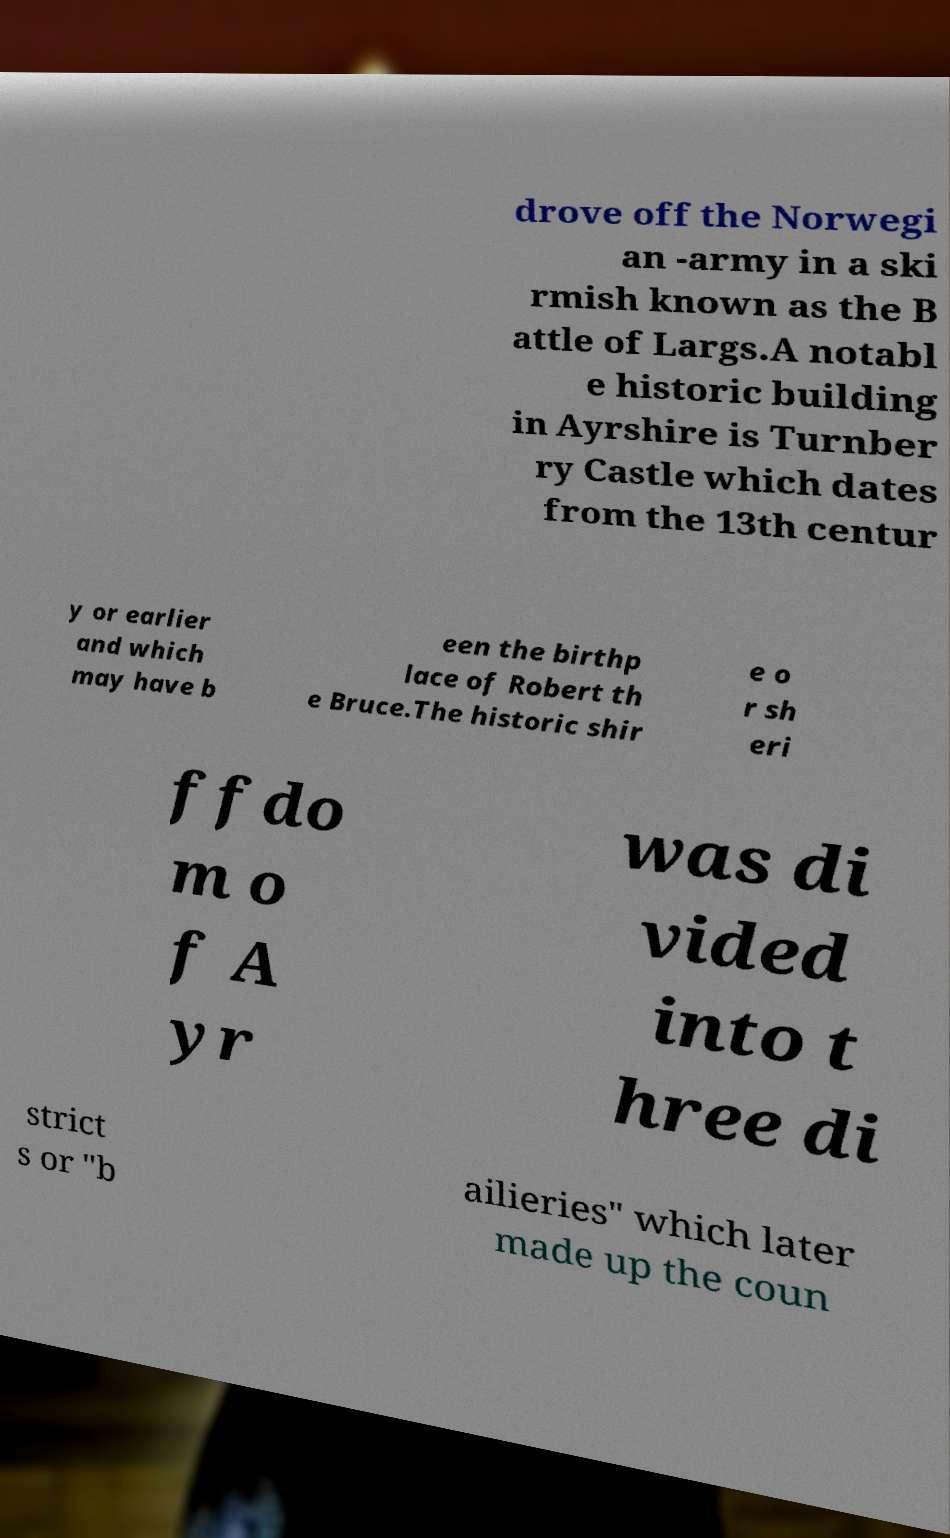Can you read and provide the text displayed in the image?This photo seems to have some interesting text. Can you extract and type it out for me? drove off the Norwegi an -army in a ski rmish known as the B attle of Largs.A notabl e historic building in Ayrshire is Turnber ry Castle which dates from the 13th centur y or earlier and which may have b een the birthp lace of Robert th e Bruce.The historic shir e o r sh eri ffdo m o f A yr was di vided into t hree di strict s or "b ailieries" which later made up the coun 